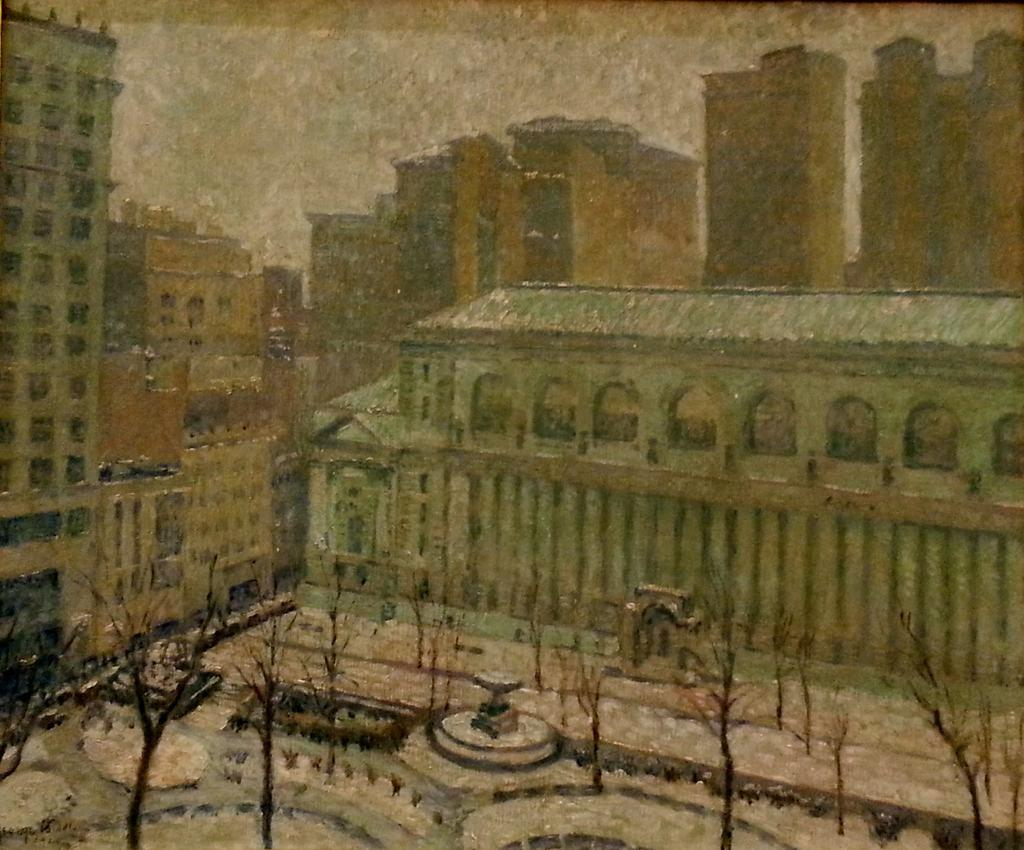What is the main subject of the image? There is a painting in the image. What is depicted in the painting? The painting contains a group of buildings. What can be seen in the sky in the painting? The sky is visible at the top of the painting. What type of vegetation is present in front of the buildings in the painting? Trees are present in front of the buildings in the painting. How many cakes are stacked on top of each other in the image? There are no cakes present in the image; it features a painting of a group of buildings with trees and a visible sky. 